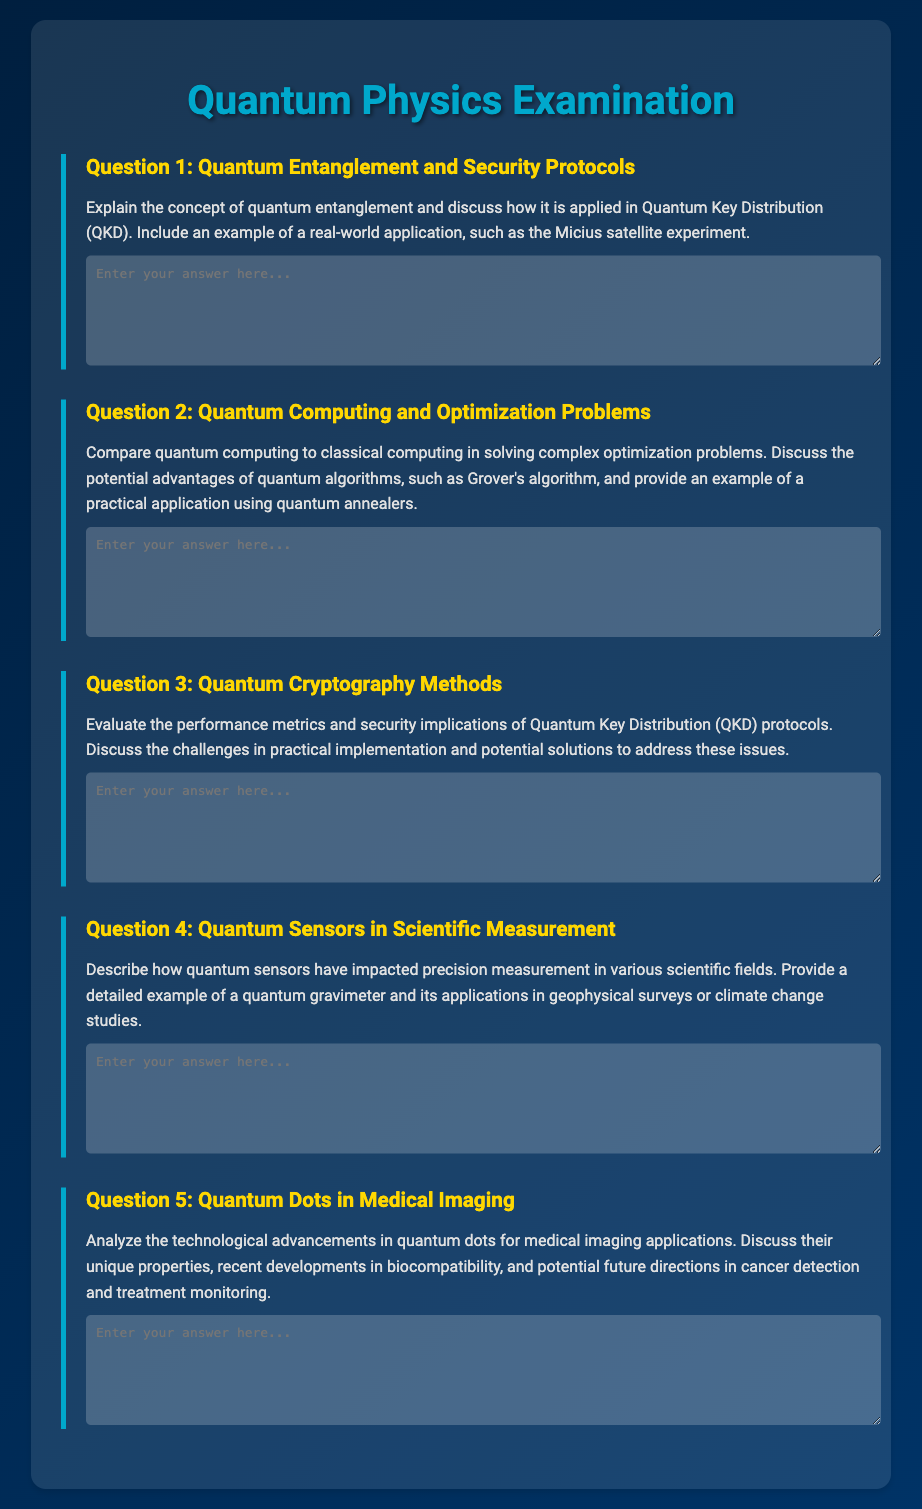What is the title of the document? The title of the document is displayed prominently at the top of the rendered HTML page.
Answer: Quantum Physics Examination How many questions are included in the document? The document contains a total of five questions, each addressing different topics related to quantum physics.
Answer: 5 What is the focus of Question 1? Question 1 is focused on explaining the concept of quantum entanglement and its application in Quantum Key Distribution.
Answer: Quantum Entanglement and Security Protocols What algorithm is mentioned in Question 2? The document specifies Grover's algorithm as a quantum algorithm highlighted in the comparison of solving optimization problems.
Answer: Grover's algorithm What specific example is requested in Question 4? The question requests a detailed example of a quantum gravimeter and its applications.
Answer: Quantum gravimeter What color is used for the section headers in the document? The section headers are colored in a specific shade that stands out against the background.
Answer: Gold Which field has seen an impact due to quantum sensors according to Question 4? The document mentions various scientific fields that have been impacted by quantum sensors in terms of precision measurement.
Answer: Scientific fields What is the main topic of Question 5? Question 5 analyzes advancements in a specific technology used in medical imaging applications.
Answer: Quantum Dots in Medical Imaging 